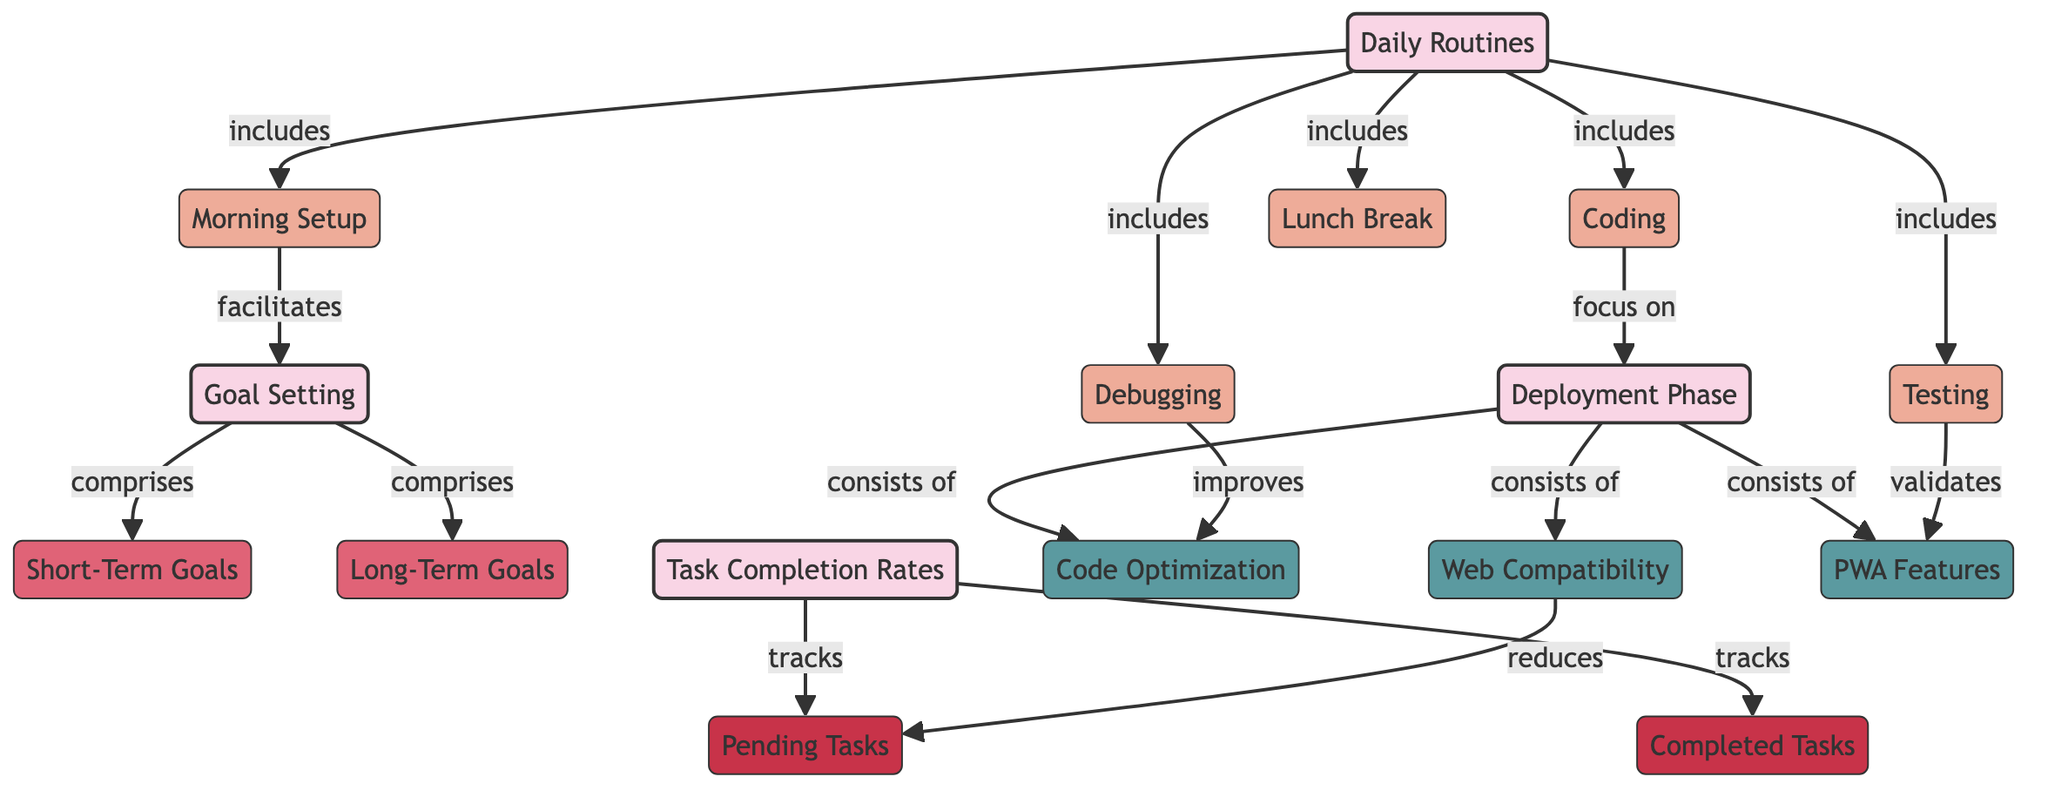What are the daily routines included in the diagram? The diagram lists five daily routines connected to the "Daily Routines" category: Morning Setup, Coding, Testing, Debugging, and Lunch Break. Therefore, these five tasks are the routines included.
Answer: Morning Setup, Coding, Testing, Debugging, Lunch Break What types of goals are established in the goal setting category? Under the "Goal Setting" category, the diagram specifies two types of goals: Short-Term Goals and Long-Term Goals. This means these are the goals that fall under this category.
Answer: Short-Term Goals, Long-Term Goals How many tasks are tracked under task completion rates? The "Task Completion Rates" category tracks two metrics: Completed Tasks and Pending Tasks. Thus, there are two tasks being tracked within this category.
Answer: 2 What activity is confirmed to validate during the testing process? The diagram indicates that Testing validates PWA Features specifically. This means that during the testing process, the validation of these features is a priority.
Answer: PWA Features Which activity is mentioned to improve code optimization? According to the diagram, Debugging is the activity that improves Code Optimization. This provides a direct link between these two aspects of the deployment phase.
Answer: Code Optimization How does the morning setup facilitate goal setting? The relationship shown in the diagram implies that the Morning Setup contributes to facilitating Goal Setting. This indicates that having a morning routine likely helps in establishing goals effectively.
Answer: Facilitates Which activity is said to reduce pending tasks? The diagram states that Web Compatibility is the activity that reduces Pending Tasks. This suggests a direct outcome of the web development work leading to fewer tasks left pending.
Answer: Reduces How many categories are present in the diagram overall? The diagram outlines four main categories: Daily Routines, Goal Setting, Task Completion Rates, and Deployment Phase. Therefore, in total, there are four distinct categories represented in the diagram.
Answer: 4 What is the relationship between coding and the deployment phase? In the diagram, Coding is stated to focus on the Deployment Phase. This implies that the coding process is directly related to activities associated with deploying the web app.
Answer: Focus on How many relationships connect the activities to the goal setting category? The diagram shows one relationship connecting the daily routine of Morning Setup to the Goal Setting category, indicating a direct influence of the routine on setting goals.
Answer: 1 